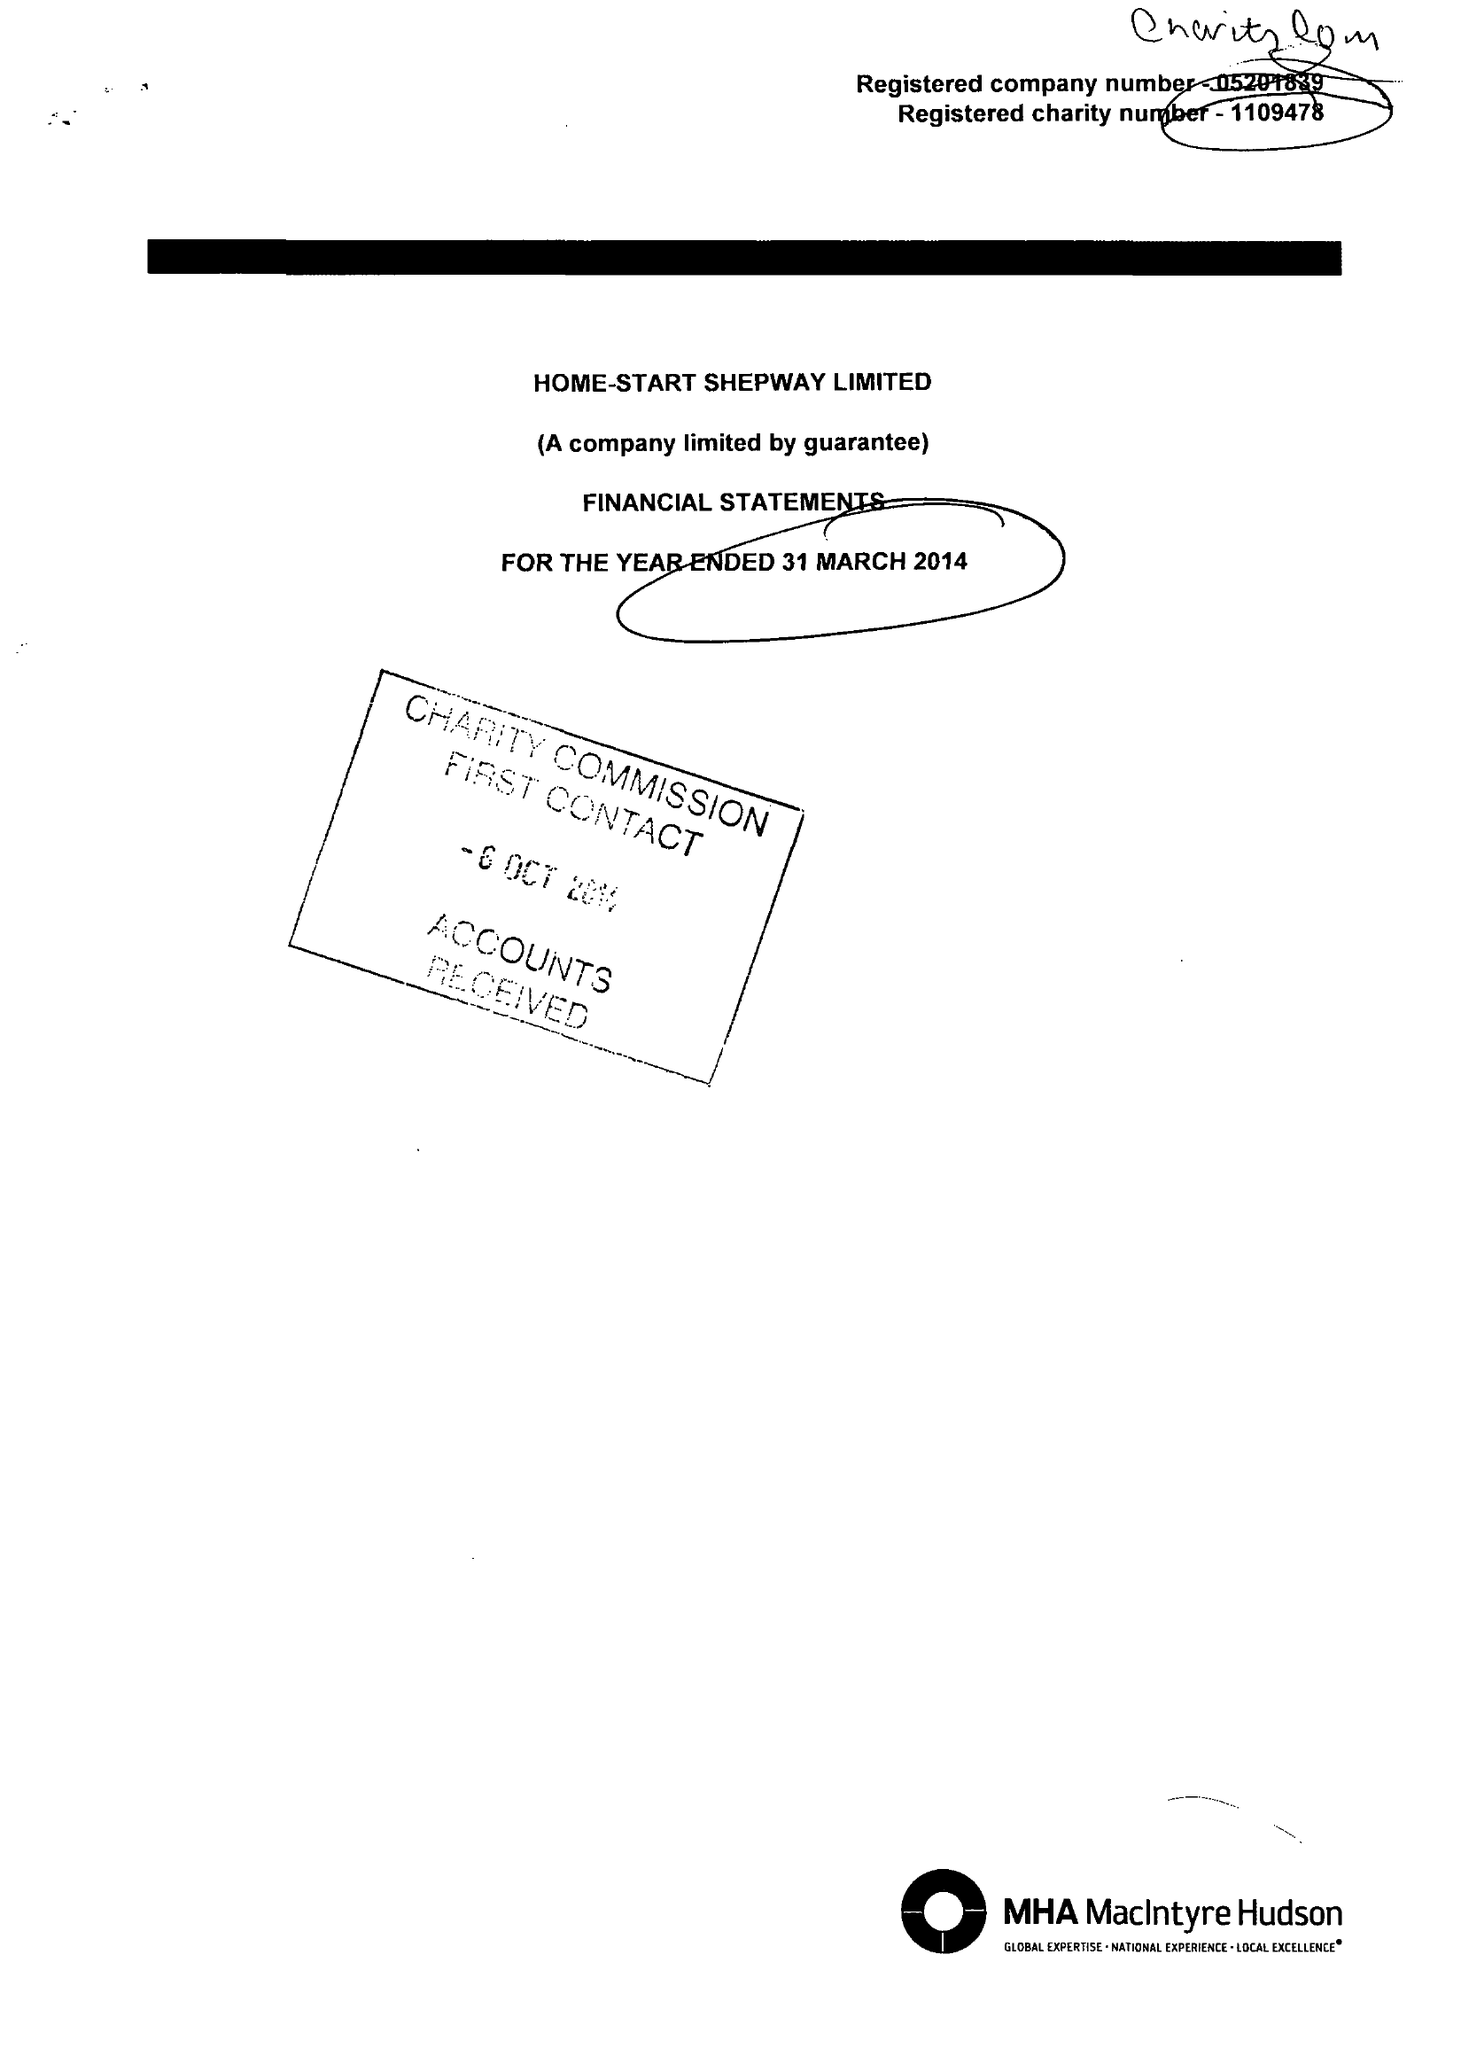What is the value for the charity_number?
Answer the question using a single word or phrase. 1109478 